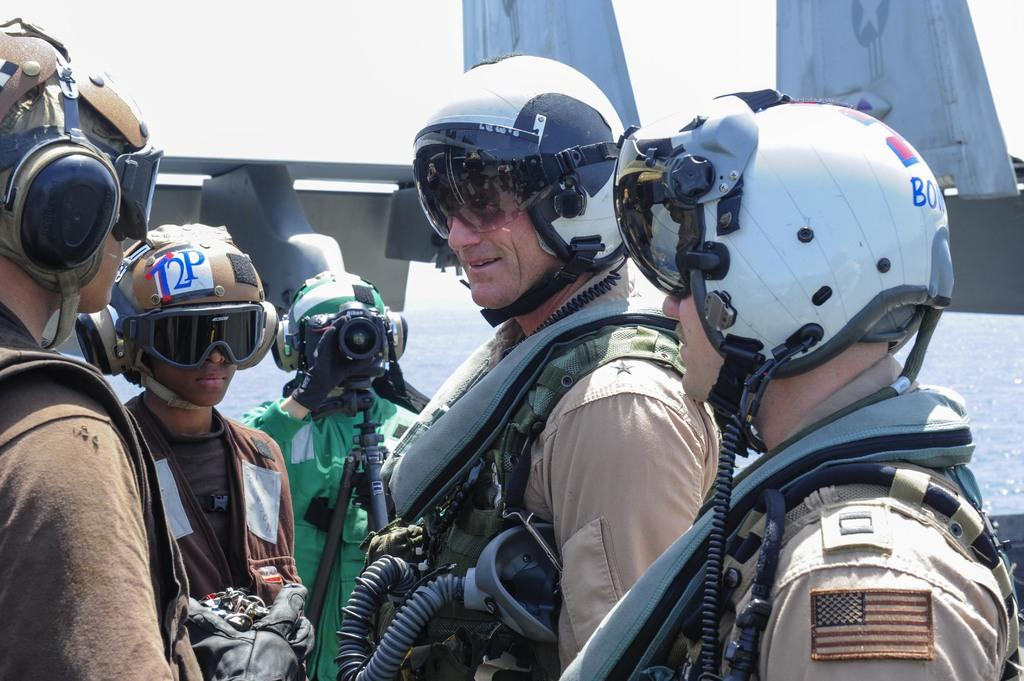Who is present in the image? There are people in the image. What are the people wearing on their heads? The people are wearing helmets. Can you describe the person holding an object in the image? There is a person holding a camera in the image. What can be seen in the distance in the image? There is water and sky visible in the background of the image, along with other objects. What type of spot can be seen on the person's helmet in the image? There is no spot visible on the person's helmet in the image. What kind of cast is being used by the person holding the camera in the image? The person holding the camera is not using a cast in the image. 